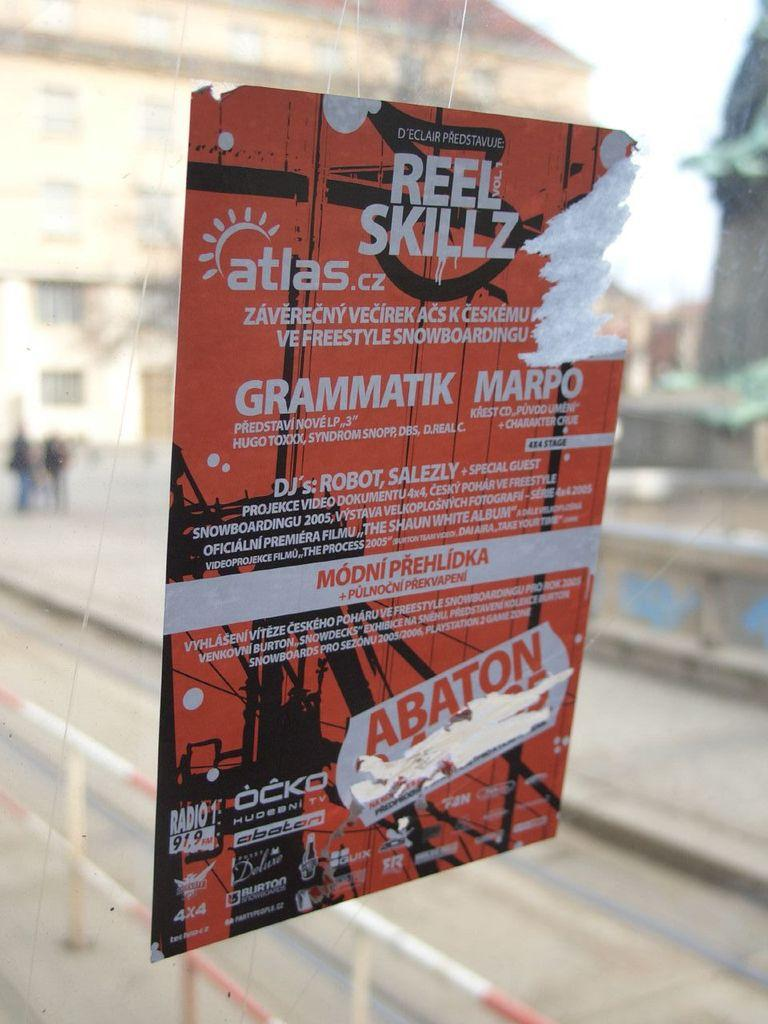<image>
Create a compact narrative representing the image presented. A sticker on a window that says Reel Skillz. 